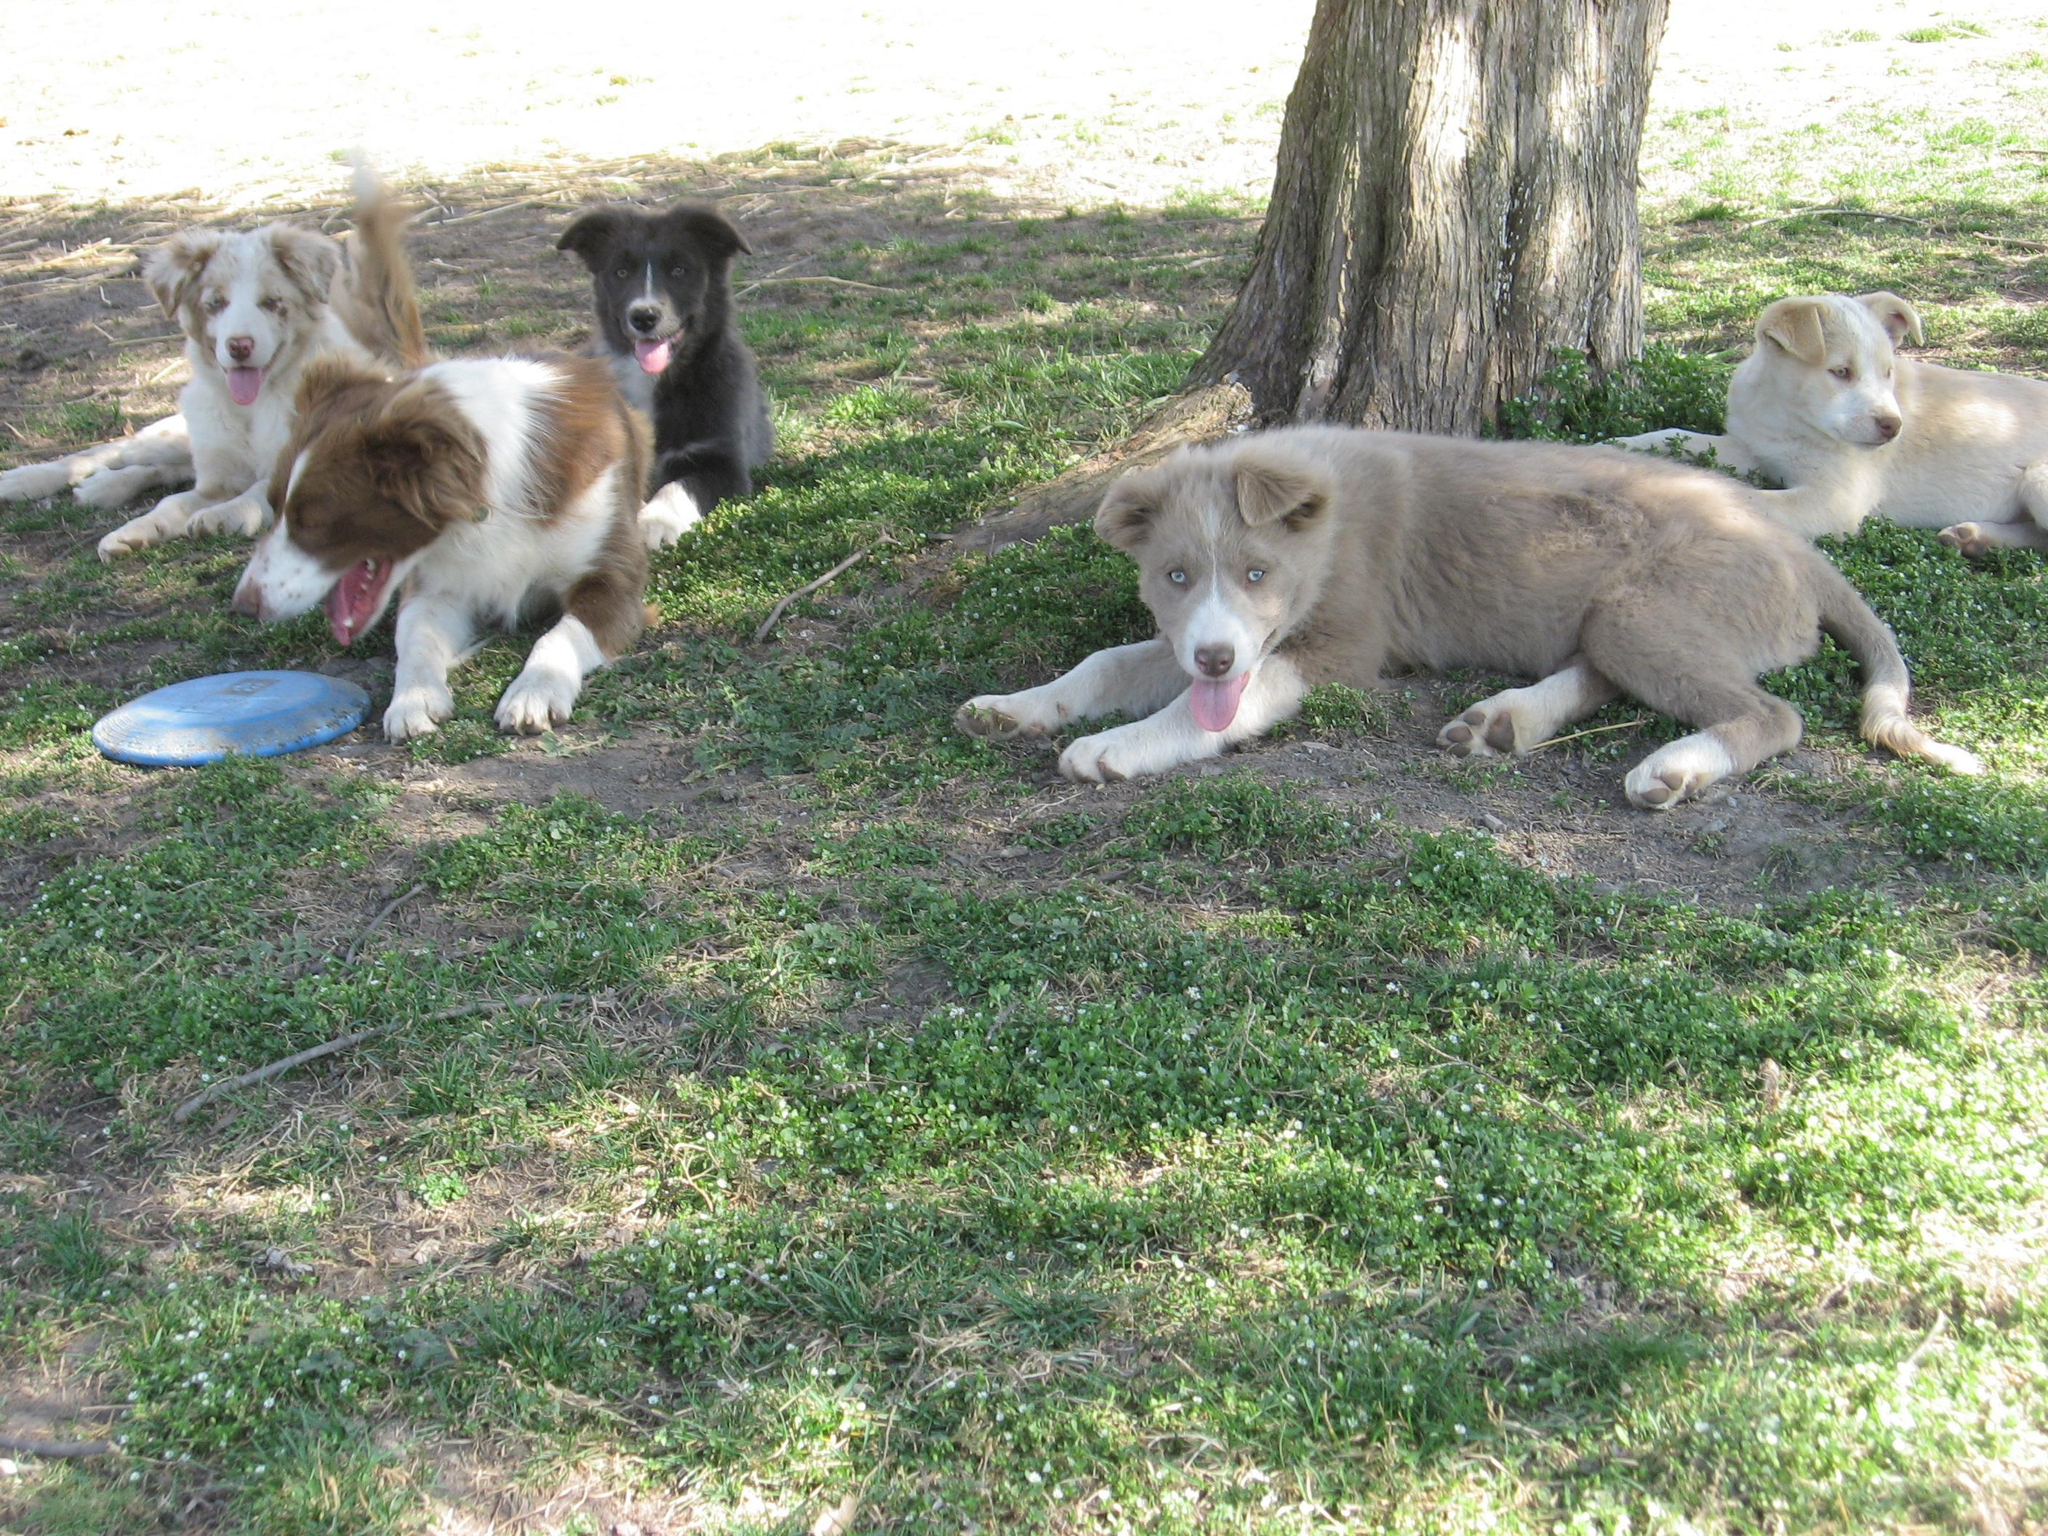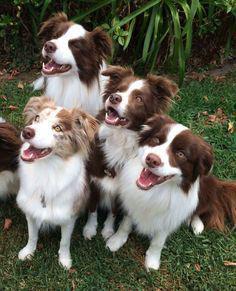The first image is the image on the left, the second image is the image on the right. Considering the images on both sides, is "There are exactly seven dogs in the image on the right." valid? Answer yes or no. No. 